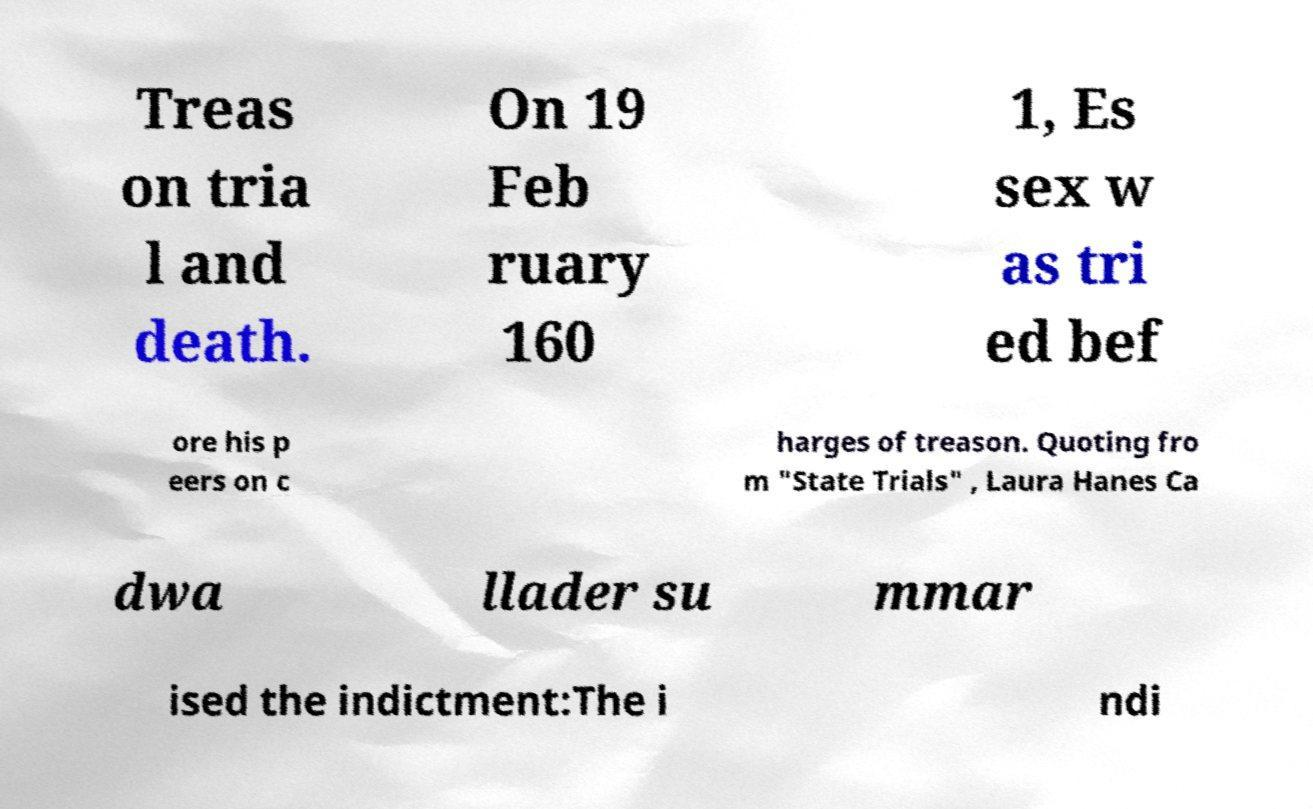Could you extract and type out the text from this image? Treas on tria l and death. On 19 Feb ruary 160 1, Es sex w as tri ed bef ore his p eers on c harges of treason. Quoting fro m "State Trials" , Laura Hanes Ca dwa llader su mmar ised the indictment:The i ndi 